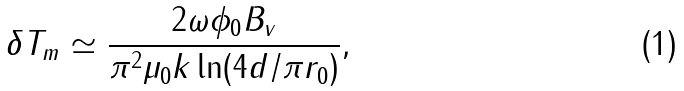<formula> <loc_0><loc_0><loc_500><loc_500>\delta T _ { m } \simeq \frac { 2 \omega \phi _ { 0 } B _ { v } } { \pi ^ { 2 } \mu _ { 0 } k \ln ( 4 d / \pi r _ { 0 } ) } ,</formula> 